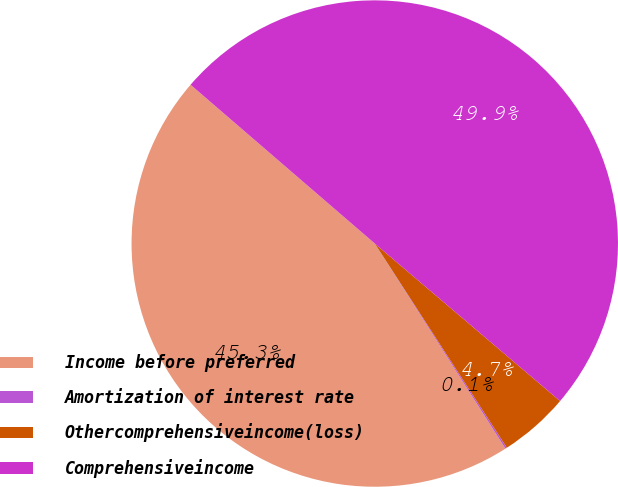Convert chart. <chart><loc_0><loc_0><loc_500><loc_500><pie_chart><fcel>Income before preferred<fcel>Amortization of interest rate<fcel>Othercomprehensiveincome(loss)<fcel>Comprehensiveincome<nl><fcel>45.35%<fcel>0.11%<fcel>4.65%<fcel>49.89%<nl></chart> 